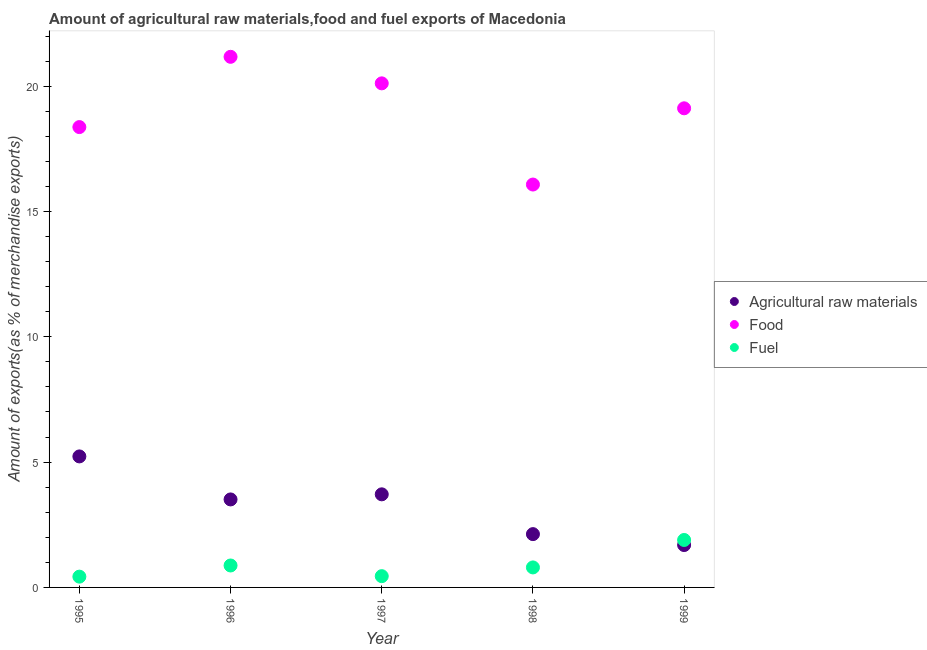Is the number of dotlines equal to the number of legend labels?
Provide a short and direct response. Yes. What is the percentage of food exports in 1996?
Provide a succinct answer. 21.17. Across all years, what is the maximum percentage of fuel exports?
Keep it short and to the point. 1.89. Across all years, what is the minimum percentage of raw materials exports?
Your answer should be compact. 1.69. In which year was the percentage of raw materials exports maximum?
Your response must be concise. 1995. What is the total percentage of raw materials exports in the graph?
Your response must be concise. 16.27. What is the difference between the percentage of food exports in 1995 and that in 1997?
Provide a succinct answer. -1.74. What is the difference between the percentage of raw materials exports in 1999 and the percentage of food exports in 1998?
Ensure brevity in your answer.  -14.38. What is the average percentage of raw materials exports per year?
Keep it short and to the point. 3.25. In the year 1997, what is the difference between the percentage of raw materials exports and percentage of food exports?
Your answer should be very brief. -16.4. In how many years, is the percentage of food exports greater than 3 %?
Offer a very short reply. 5. What is the ratio of the percentage of fuel exports in 1995 to that in 1996?
Provide a short and direct response. 0.49. Is the difference between the percentage of raw materials exports in 1995 and 1997 greater than the difference between the percentage of food exports in 1995 and 1997?
Offer a terse response. Yes. What is the difference between the highest and the second highest percentage of raw materials exports?
Provide a short and direct response. 1.51. What is the difference between the highest and the lowest percentage of raw materials exports?
Give a very brief answer. 3.54. Is it the case that in every year, the sum of the percentage of raw materials exports and percentage of food exports is greater than the percentage of fuel exports?
Keep it short and to the point. Yes. Does the percentage of fuel exports monotonically increase over the years?
Offer a very short reply. No. How are the legend labels stacked?
Provide a succinct answer. Vertical. What is the title of the graph?
Offer a terse response. Amount of agricultural raw materials,food and fuel exports of Macedonia. What is the label or title of the X-axis?
Your answer should be compact. Year. What is the label or title of the Y-axis?
Your response must be concise. Amount of exports(as % of merchandise exports). What is the Amount of exports(as % of merchandise exports) in Agricultural raw materials in 1995?
Offer a very short reply. 5.23. What is the Amount of exports(as % of merchandise exports) in Food in 1995?
Your response must be concise. 18.37. What is the Amount of exports(as % of merchandise exports) of Fuel in 1995?
Give a very brief answer. 0.43. What is the Amount of exports(as % of merchandise exports) of Agricultural raw materials in 1996?
Ensure brevity in your answer.  3.51. What is the Amount of exports(as % of merchandise exports) in Food in 1996?
Your answer should be very brief. 21.17. What is the Amount of exports(as % of merchandise exports) of Fuel in 1996?
Offer a very short reply. 0.88. What is the Amount of exports(as % of merchandise exports) in Agricultural raw materials in 1997?
Your answer should be very brief. 3.71. What is the Amount of exports(as % of merchandise exports) in Food in 1997?
Your answer should be compact. 20.11. What is the Amount of exports(as % of merchandise exports) in Fuel in 1997?
Make the answer very short. 0.45. What is the Amount of exports(as % of merchandise exports) of Agricultural raw materials in 1998?
Your answer should be compact. 2.13. What is the Amount of exports(as % of merchandise exports) in Food in 1998?
Provide a short and direct response. 16.08. What is the Amount of exports(as % of merchandise exports) of Fuel in 1998?
Keep it short and to the point. 0.8. What is the Amount of exports(as % of merchandise exports) of Agricultural raw materials in 1999?
Keep it short and to the point. 1.69. What is the Amount of exports(as % of merchandise exports) in Food in 1999?
Your answer should be compact. 19.12. What is the Amount of exports(as % of merchandise exports) of Fuel in 1999?
Provide a short and direct response. 1.89. Across all years, what is the maximum Amount of exports(as % of merchandise exports) in Agricultural raw materials?
Give a very brief answer. 5.23. Across all years, what is the maximum Amount of exports(as % of merchandise exports) in Food?
Ensure brevity in your answer.  21.17. Across all years, what is the maximum Amount of exports(as % of merchandise exports) of Fuel?
Your answer should be compact. 1.89. Across all years, what is the minimum Amount of exports(as % of merchandise exports) of Agricultural raw materials?
Make the answer very short. 1.69. Across all years, what is the minimum Amount of exports(as % of merchandise exports) in Food?
Provide a succinct answer. 16.08. Across all years, what is the minimum Amount of exports(as % of merchandise exports) in Fuel?
Provide a succinct answer. 0.43. What is the total Amount of exports(as % of merchandise exports) in Agricultural raw materials in the graph?
Your answer should be very brief. 16.27. What is the total Amount of exports(as % of merchandise exports) in Food in the graph?
Make the answer very short. 94.84. What is the total Amount of exports(as % of merchandise exports) of Fuel in the graph?
Provide a succinct answer. 4.45. What is the difference between the Amount of exports(as % of merchandise exports) of Agricultural raw materials in 1995 and that in 1996?
Provide a short and direct response. 1.72. What is the difference between the Amount of exports(as % of merchandise exports) of Food in 1995 and that in 1996?
Provide a short and direct response. -2.8. What is the difference between the Amount of exports(as % of merchandise exports) in Fuel in 1995 and that in 1996?
Offer a terse response. -0.45. What is the difference between the Amount of exports(as % of merchandise exports) of Agricultural raw materials in 1995 and that in 1997?
Ensure brevity in your answer.  1.51. What is the difference between the Amount of exports(as % of merchandise exports) in Food in 1995 and that in 1997?
Offer a very short reply. -1.74. What is the difference between the Amount of exports(as % of merchandise exports) of Fuel in 1995 and that in 1997?
Your answer should be compact. -0.02. What is the difference between the Amount of exports(as % of merchandise exports) of Agricultural raw materials in 1995 and that in 1998?
Your answer should be compact. 3.1. What is the difference between the Amount of exports(as % of merchandise exports) in Food in 1995 and that in 1998?
Offer a terse response. 2.29. What is the difference between the Amount of exports(as % of merchandise exports) in Fuel in 1995 and that in 1998?
Your answer should be compact. -0.37. What is the difference between the Amount of exports(as % of merchandise exports) in Agricultural raw materials in 1995 and that in 1999?
Your response must be concise. 3.54. What is the difference between the Amount of exports(as % of merchandise exports) of Food in 1995 and that in 1999?
Your answer should be compact. -0.75. What is the difference between the Amount of exports(as % of merchandise exports) in Fuel in 1995 and that in 1999?
Your answer should be compact. -1.46. What is the difference between the Amount of exports(as % of merchandise exports) in Agricultural raw materials in 1996 and that in 1997?
Ensure brevity in your answer.  -0.2. What is the difference between the Amount of exports(as % of merchandise exports) of Food in 1996 and that in 1997?
Your answer should be compact. 1.06. What is the difference between the Amount of exports(as % of merchandise exports) in Fuel in 1996 and that in 1997?
Give a very brief answer. 0.43. What is the difference between the Amount of exports(as % of merchandise exports) in Agricultural raw materials in 1996 and that in 1998?
Give a very brief answer. 1.38. What is the difference between the Amount of exports(as % of merchandise exports) in Food in 1996 and that in 1998?
Your answer should be very brief. 5.1. What is the difference between the Amount of exports(as % of merchandise exports) in Fuel in 1996 and that in 1998?
Provide a succinct answer. 0.08. What is the difference between the Amount of exports(as % of merchandise exports) of Agricultural raw materials in 1996 and that in 1999?
Give a very brief answer. 1.82. What is the difference between the Amount of exports(as % of merchandise exports) in Food in 1996 and that in 1999?
Your answer should be very brief. 2.05. What is the difference between the Amount of exports(as % of merchandise exports) in Fuel in 1996 and that in 1999?
Give a very brief answer. -1.02. What is the difference between the Amount of exports(as % of merchandise exports) in Agricultural raw materials in 1997 and that in 1998?
Ensure brevity in your answer.  1.59. What is the difference between the Amount of exports(as % of merchandise exports) of Food in 1997 and that in 1998?
Ensure brevity in your answer.  4.04. What is the difference between the Amount of exports(as % of merchandise exports) in Fuel in 1997 and that in 1998?
Offer a very short reply. -0.35. What is the difference between the Amount of exports(as % of merchandise exports) of Agricultural raw materials in 1997 and that in 1999?
Your response must be concise. 2.02. What is the difference between the Amount of exports(as % of merchandise exports) in Fuel in 1997 and that in 1999?
Provide a succinct answer. -1.44. What is the difference between the Amount of exports(as % of merchandise exports) in Agricultural raw materials in 1998 and that in 1999?
Ensure brevity in your answer.  0.44. What is the difference between the Amount of exports(as % of merchandise exports) in Food in 1998 and that in 1999?
Ensure brevity in your answer.  -3.04. What is the difference between the Amount of exports(as % of merchandise exports) of Fuel in 1998 and that in 1999?
Your response must be concise. -1.1. What is the difference between the Amount of exports(as % of merchandise exports) in Agricultural raw materials in 1995 and the Amount of exports(as % of merchandise exports) in Food in 1996?
Your answer should be compact. -15.94. What is the difference between the Amount of exports(as % of merchandise exports) in Agricultural raw materials in 1995 and the Amount of exports(as % of merchandise exports) in Fuel in 1996?
Your answer should be compact. 4.35. What is the difference between the Amount of exports(as % of merchandise exports) in Food in 1995 and the Amount of exports(as % of merchandise exports) in Fuel in 1996?
Your response must be concise. 17.49. What is the difference between the Amount of exports(as % of merchandise exports) in Agricultural raw materials in 1995 and the Amount of exports(as % of merchandise exports) in Food in 1997?
Provide a succinct answer. -14.89. What is the difference between the Amount of exports(as % of merchandise exports) in Agricultural raw materials in 1995 and the Amount of exports(as % of merchandise exports) in Fuel in 1997?
Keep it short and to the point. 4.78. What is the difference between the Amount of exports(as % of merchandise exports) in Food in 1995 and the Amount of exports(as % of merchandise exports) in Fuel in 1997?
Provide a short and direct response. 17.92. What is the difference between the Amount of exports(as % of merchandise exports) in Agricultural raw materials in 1995 and the Amount of exports(as % of merchandise exports) in Food in 1998?
Provide a succinct answer. -10.85. What is the difference between the Amount of exports(as % of merchandise exports) in Agricultural raw materials in 1995 and the Amount of exports(as % of merchandise exports) in Fuel in 1998?
Ensure brevity in your answer.  4.43. What is the difference between the Amount of exports(as % of merchandise exports) of Food in 1995 and the Amount of exports(as % of merchandise exports) of Fuel in 1998?
Keep it short and to the point. 17.57. What is the difference between the Amount of exports(as % of merchandise exports) of Agricultural raw materials in 1995 and the Amount of exports(as % of merchandise exports) of Food in 1999?
Provide a short and direct response. -13.89. What is the difference between the Amount of exports(as % of merchandise exports) of Agricultural raw materials in 1995 and the Amount of exports(as % of merchandise exports) of Fuel in 1999?
Ensure brevity in your answer.  3.33. What is the difference between the Amount of exports(as % of merchandise exports) in Food in 1995 and the Amount of exports(as % of merchandise exports) in Fuel in 1999?
Offer a very short reply. 16.47. What is the difference between the Amount of exports(as % of merchandise exports) of Agricultural raw materials in 1996 and the Amount of exports(as % of merchandise exports) of Food in 1997?
Your answer should be very brief. -16.6. What is the difference between the Amount of exports(as % of merchandise exports) of Agricultural raw materials in 1996 and the Amount of exports(as % of merchandise exports) of Fuel in 1997?
Offer a terse response. 3.06. What is the difference between the Amount of exports(as % of merchandise exports) in Food in 1996 and the Amount of exports(as % of merchandise exports) in Fuel in 1997?
Provide a short and direct response. 20.72. What is the difference between the Amount of exports(as % of merchandise exports) in Agricultural raw materials in 1996 and the Amount of exports(as % of merchandise exports) in Food in 1998?
Make the answer very short. -12.56. What is the difference between the Amount of exports(as % of merchandise exports) in Agricultural raw materials in 1996 and the Amount of exports(as % of merchandise exports) in Fuel in 1998?
Your response must be concise. 2.71. What is the difference between the Amount of exports(as % of merchandise exports) of Food in 1996 and the Amount of exports(as % of merchandise exports) of Fuel in 1998?
Offer a terse response. 20.37. What is the difference between the Amount of exports(as % of merchandise exports) of Agricultural raw materials in 1996 and the Amount of exports(as % of merchandise exports) of Food in 1999?
Keep it short and to the point. -15.61. What is the difference between the Amount of exports(as % of merchandise exports) in Agricultural raw materials in 1996 and the Amount of exports(as % of merchandise exports) in Fuel in 1999?
Make the answer very short. 1.62. What is the difference between the Amount of exports(as % of merchandise exports) of Food in 1996 and the Amount of exports(as % of merchandise exports) of Fuel in 1999?
Make the answer very short. 19.28. What is the difference between the Amount of exports(as % of merchandise exports) in Agricultural raw materials in 1997 and the Amount of exports(as % of merchandise exports) in Food in 1998?
Your answer should be compact. -12.36. What is the difference between the Amount of exports(as % of merchandise exports) in Agricultural raw materials in 1997 and the Amount of exports(as % of merchandise exports) in Fuel in 1998?
Offer a very short reply. 2.92. What is the difference between the Amount of exports(as % of merchandise exports) of Food in 1997 and the Amount of exports(as % of merchandise exports) of Fuel in 1998?
Make the answer very short. 19.31. What is the difference between the Amount of exports(as % of merchandise exports) in Agricultural raw materials in 1997 and the Amount of exports(as % of merchandise exports) in Food in 1999?
Offer a very short reply. -15.4. What is the difference between the Amount of exports(as % of merchandise exports) in Agricultural raw materials in 1997 and the Amount of exports(as % of merchandise exports) in Fuel in 1999?
Your response must be concise. 1.82. What is the difference between the Amount of exports(as % of merchandise exports) in Food in 1997 and the Amount of exports(as % of merchandise exports) in Fuel in 1999?
Give a very brief answer. 18.22. What is the difference between the Amount of exports(as % of merchandise exports) in Agricultural raw materials in 1998 and the Amount of exports(as % of merchandise exports) in Food in 1999?
Ensure brevity in your answer.  -16.99. What is the difference between the Amount of exports(as % of merchandise exports) of Agricultural raw materials in 1998 and the Amount of exports(as % of merchandise exports) of Fuel in 1999?
Provide a short and direct response. 0.23. What is the difference between the Amount of exports(as % of merchandise exports) of Food in 1998 and the Amount of exports(as % of merchandise exports) of Fuel in 1999?
Provide a succinct answer. 14.18. What is the average Amount of exports(as % of merchandise exports) of Agricultural raw materials per year?
Provide a short and direct response. 3.25. What is the average Amount of exports(as % of merchandise exports) of Food per year?
Make the answer very short. 18.97. What is the average Amount of exports(as % of merchandise exports) in Fuel per year?
Your answer should be very brief. 0.89. In the year 1995, what is the difference between the Amount of exports(as % of merchandise exports) of Agricultural raw materials and Amount of exports(as % of merchandise exports) of Food?
Offer a terse response. -13.14. In the year 1995, what is the difference between the Amount of exports(as % of merchandise exports) of Agricultural raw materials and Amount of exports(as % of merchandise exports) of Fuel?
Offer a very short reply. 4.8. In the year 1995, what is the difference between the Amount of exports(as % of merchandise exports) of Food and Amount of exports(as % of merchandise exports) of Fuel?
Offer a terse response. 17.94. In the year 1996, what is the difference between the Amount of exports(as % of merchandise exports) of Agricultural raw materials and Amount of exports(as % of merchandise exports) of Food?
Provide a succinct answer. -17.66. In the year 1996, what is the difference between the Amount of exports(as % of merchandise exports) of Agricultural raw materials and Amount of exports(as % of merchandise exports) of Fuel?
Provide a succinct answer. 2.64. In the year 1996, what is the difference between the Amount of exports(as % of merchandise exports) in Food and Amount of exports(as % of merchandise exports) in Fuel?
Offer a terse response. 20.3. In the year 1997, what is the difference between the Amount of exports(as % of merchandise exports) of Agricultural raw materials and Amount of exports(as % of merchandise exports) of Food?
Ensure brevity in your answer.  -16.4. In the year 1997, what is the difference between the Amount of exports(as % of merchandise exports) of Agricultural raw materials and Amount of exports(as % of merchandise exports) of Fuel?
Make the answer very short. 3.27. In the year 1997, what is the difference between the Amount of exports(as % of merchandise exports) in Food and Amount of exports(as % of merchandise exports) in Fuel?
Your answer should be very brief. 19.66. In the year 1998, what is the difference between the Amount of exports(as % of merchandise exports) of Agricultural raw materials and Amount of exports(as % of merchandise exports) of Food?
Your response must be concise. -13.95. In the year 1998, what is the difference between the Amount of exports(as % of merchandise exports) in Agricultural raw materials and Amount of exports(as % of merchandise exports) in Fuel?
Offer a terse response. 1.33. In the year 1998, what is the difference between the Amount of exports(as % of merchandise exports) of Food and Amount of exports(as % of merchandise exports) of Fuel?
Provide a succinct answer. 15.28. In the year 1999, what is the difference between the Amount of exports(as % of merchandise exports) of Agricultural raw materials and Amount of exports(as % of merchandise exports) of Food?
Your answer should be very brief. -17.43. In the year 1999, what is the difference between the Amount of exports(as % of merchandise exports) in Agricultural raw materials and Amount of exports(as % of merchandise exports) in Fuel?
Provide a succinct answer. -0.2. In the year 1999, what is the difference between the Amount of exports(as % of merchandise exports) in Food and Amount of exports(as % of merchandise exports) in Fuel?
Offer a very short reply. 17.22. What is the ratio of the Amount of exports(as % of merchandise exports) in Agricultural raw materials in 1995 to that in 1996?
Your answer should be compact. 1.49. What is the ratio of the Amount of exports(as % of merchandise exports) in Food in 1995 to that in 1996?
Provide a short and direct response. 0.87. What is the ratio of the Amount of exports(as % of merchandise exports) of Fuel in 1995 to that in 1996?
Give a very brief answer. 0.49. What is the ratio of the Amount of exports(as % of merchandise exports) in Agricultural raw materials in 1995 to that in 1997?
Keep it short and to the point. 1.41. What is the ratio of the Amount of exports(as % of merchandise exports) of Food in 1995 to that in 1997?
Offer a terse response. 0.91. What is the ratio of the Amount of exports(as % of merchandise exports) in Fuel in 1995 to that in 1997?
Offer a terse response. 0.96. What is the ratio of the Amount of exports(as % of merchandise exports) in Agricultural raw materials in 1995 to that in 1998?
Provide a short and direct response. 2.46. What is the ratio of the Amount of exports(as % of merchandise exports) in Food in 1995 to that in 1998?
Your answer should be compact. 1.14. What is the ratio of the Amount of exports(as % of merchandise exports) in Fuel in 1995 to that in 1998?
Your answer should be very brief. 0.54. What is the ratio of the Amount of exports(as % of merchandise exports) in Agricultural raw materials in 1995 to that in 1999?
Make the answer very short. 3.09. What is the ratio of the Amount of exports(as % of merchandise exports) of Food in 1995 to that in 1999?
Your response must be concise. 0.96. What is the ratio of the Amount of exports(as % of merchandise exports) in Fuel in 1995 to that in 1999?
Your answer should be compact. 0.23. What is the ratio of the Amount of exports(as % of merchandise exports) in Agricultural raw materials in 1996 to that in 1997?
Keep it short and to the point. 0.95. What is the ratio of the Amount of exports(as % of merchandise exports) of Food in 1996 to that in 1997?
Keep it short and to the point. 1.05. What is the ratio of the Amount of exports(as % of merchandise exports) of Fuel in 1996 to that in 1997?
Offer a terse response. 1.95. What is the ratio of the Amount of exports(as % of merchandise exports) in Agricultural raw materials in 1996 to that in 1998?
Offer a very short reply. 1.65. What is the ratio of the Amount of exports(as % of merchandise exports) in Food in 1996 to that in 1998?
Your answer should be compact. 1.32. What is the ratio of the Amount of exports(as % of merchandise exports) of Fuel in 1996 to that in 1998?
Your answer should be compact. 1.1. What is the ratio of the Amount of exports(as % of merchandise exports) in Agricultural raw materials in 1996 to that in 1999?
Your answer should be very brief. 2.08. What is the ratio of the Amount of exports(as % of merchandise exports) of Food in 1996 to that in 1999?
Ensure brevity in your answer.  1.11. What is the ratio of the Amount of exports(as % of merchandise exports) in Fuel in 1996 to that in 1999?
Give a very brief answer. 0.46. What is the ratio of the Amount of exports(as % of merchandise exports) of Agricultural raw materials in 1997 to that in 1998?
Provide a succinct answer. 1.75. What is the ratio of the Amount of exports(as % of merchandise exports) of Food in 1997 to that in 1998?
Your answer should be compact. 1.25. What is the ratio of the Amount of exports(as % of merchandise exports) in Fuel in 1997 to that in 1998?
Make the answer very short. 0.56. What is the ratio of the Amount of exports(as % of merchandise exports) in Agricultural raw materials in 1997 to that in 1999?
Make the answer very short. 2.2. What is the ratio of the Amount of exports(as % of merchandise exports) in Food in 1997 to that in 1999?
Your response must be concise. 1.05. What is the ratio of the Amount of exports(as % of merchandise exports) in Fuel in 1997 to that in 1999?
Your response must be concise. 0.24. What is the ratio of the Amount of exports(as % of merchandise exports) in Agricultural raw materials in 1998 to that in 1999?
Provide a succinct answer. 1.26. What is the ratio of the Amount of exports(as % of merchandise exports) of Food in 1998 to that in 1999?
Give a very brief answer. 0.84. What is the ratio of the Amount of exports(as % of merchandise exports) in Fuel in 1998 to that in 1999?
Your response must be concise. 0.42. What is the difference between the highest and the second highest Amount of exports(as % of merchandise exports) in Agricultural raw materials?
Provide a short and direct response. 1.51. What is the difference between the highest and the second highest Amount of exports(as % of merchandise exports) of Food?
Provide a short and direct response. 1.06. What is the difference between the highest and the second highest Amount of exports(as % of merchandise exports) in Fuel?
Ensure brevity in your answer.  1.02. What is the difference between the highest and the lowest Amount of exports(as % of merchandise exports) of Agricultural raw materials?
Ensure brevity in your answer.  3.54. What is the difference between the highest and the lowest Amount of exports(as % of merchandise exports) in Food?
Provide a short and direct response. 5.1. What is the difference between the highest and the lowest Amount of exports(as % of merchandise exports) of Fuel?
Provide a succinct answer. 1.46. 